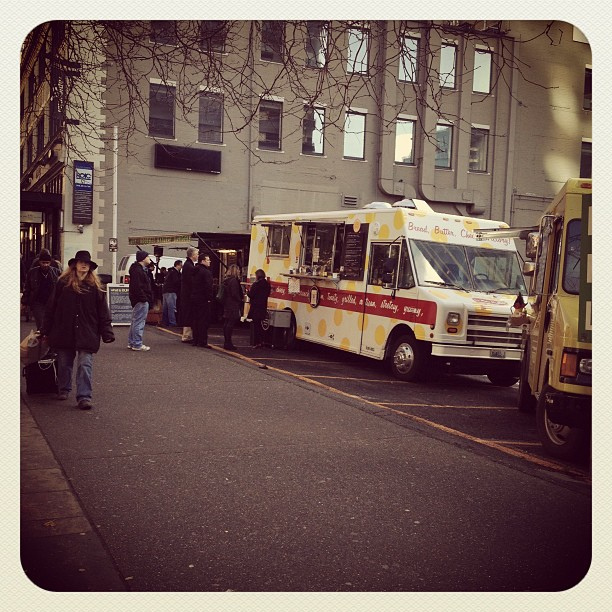How many people can you see? 2 